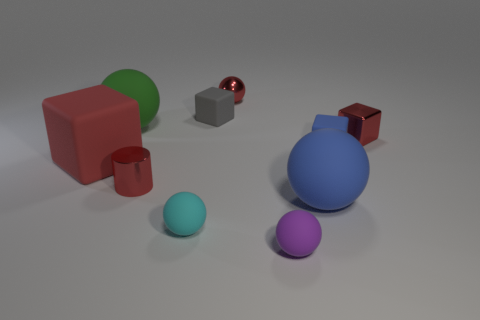How many objects are there in total, and which is the largest? In total, there are ten objects in the image. The largest object is the big blue sphere. What can you infer about the texture of these objects? The spheres have a smooth surface, suggesting they might have a rubbery or plastic texture. The cubes and the cuboid have a more matte finish, indicating they could be made of a different material, possibly wood or metal for the cuboid, given its reflective surface. 